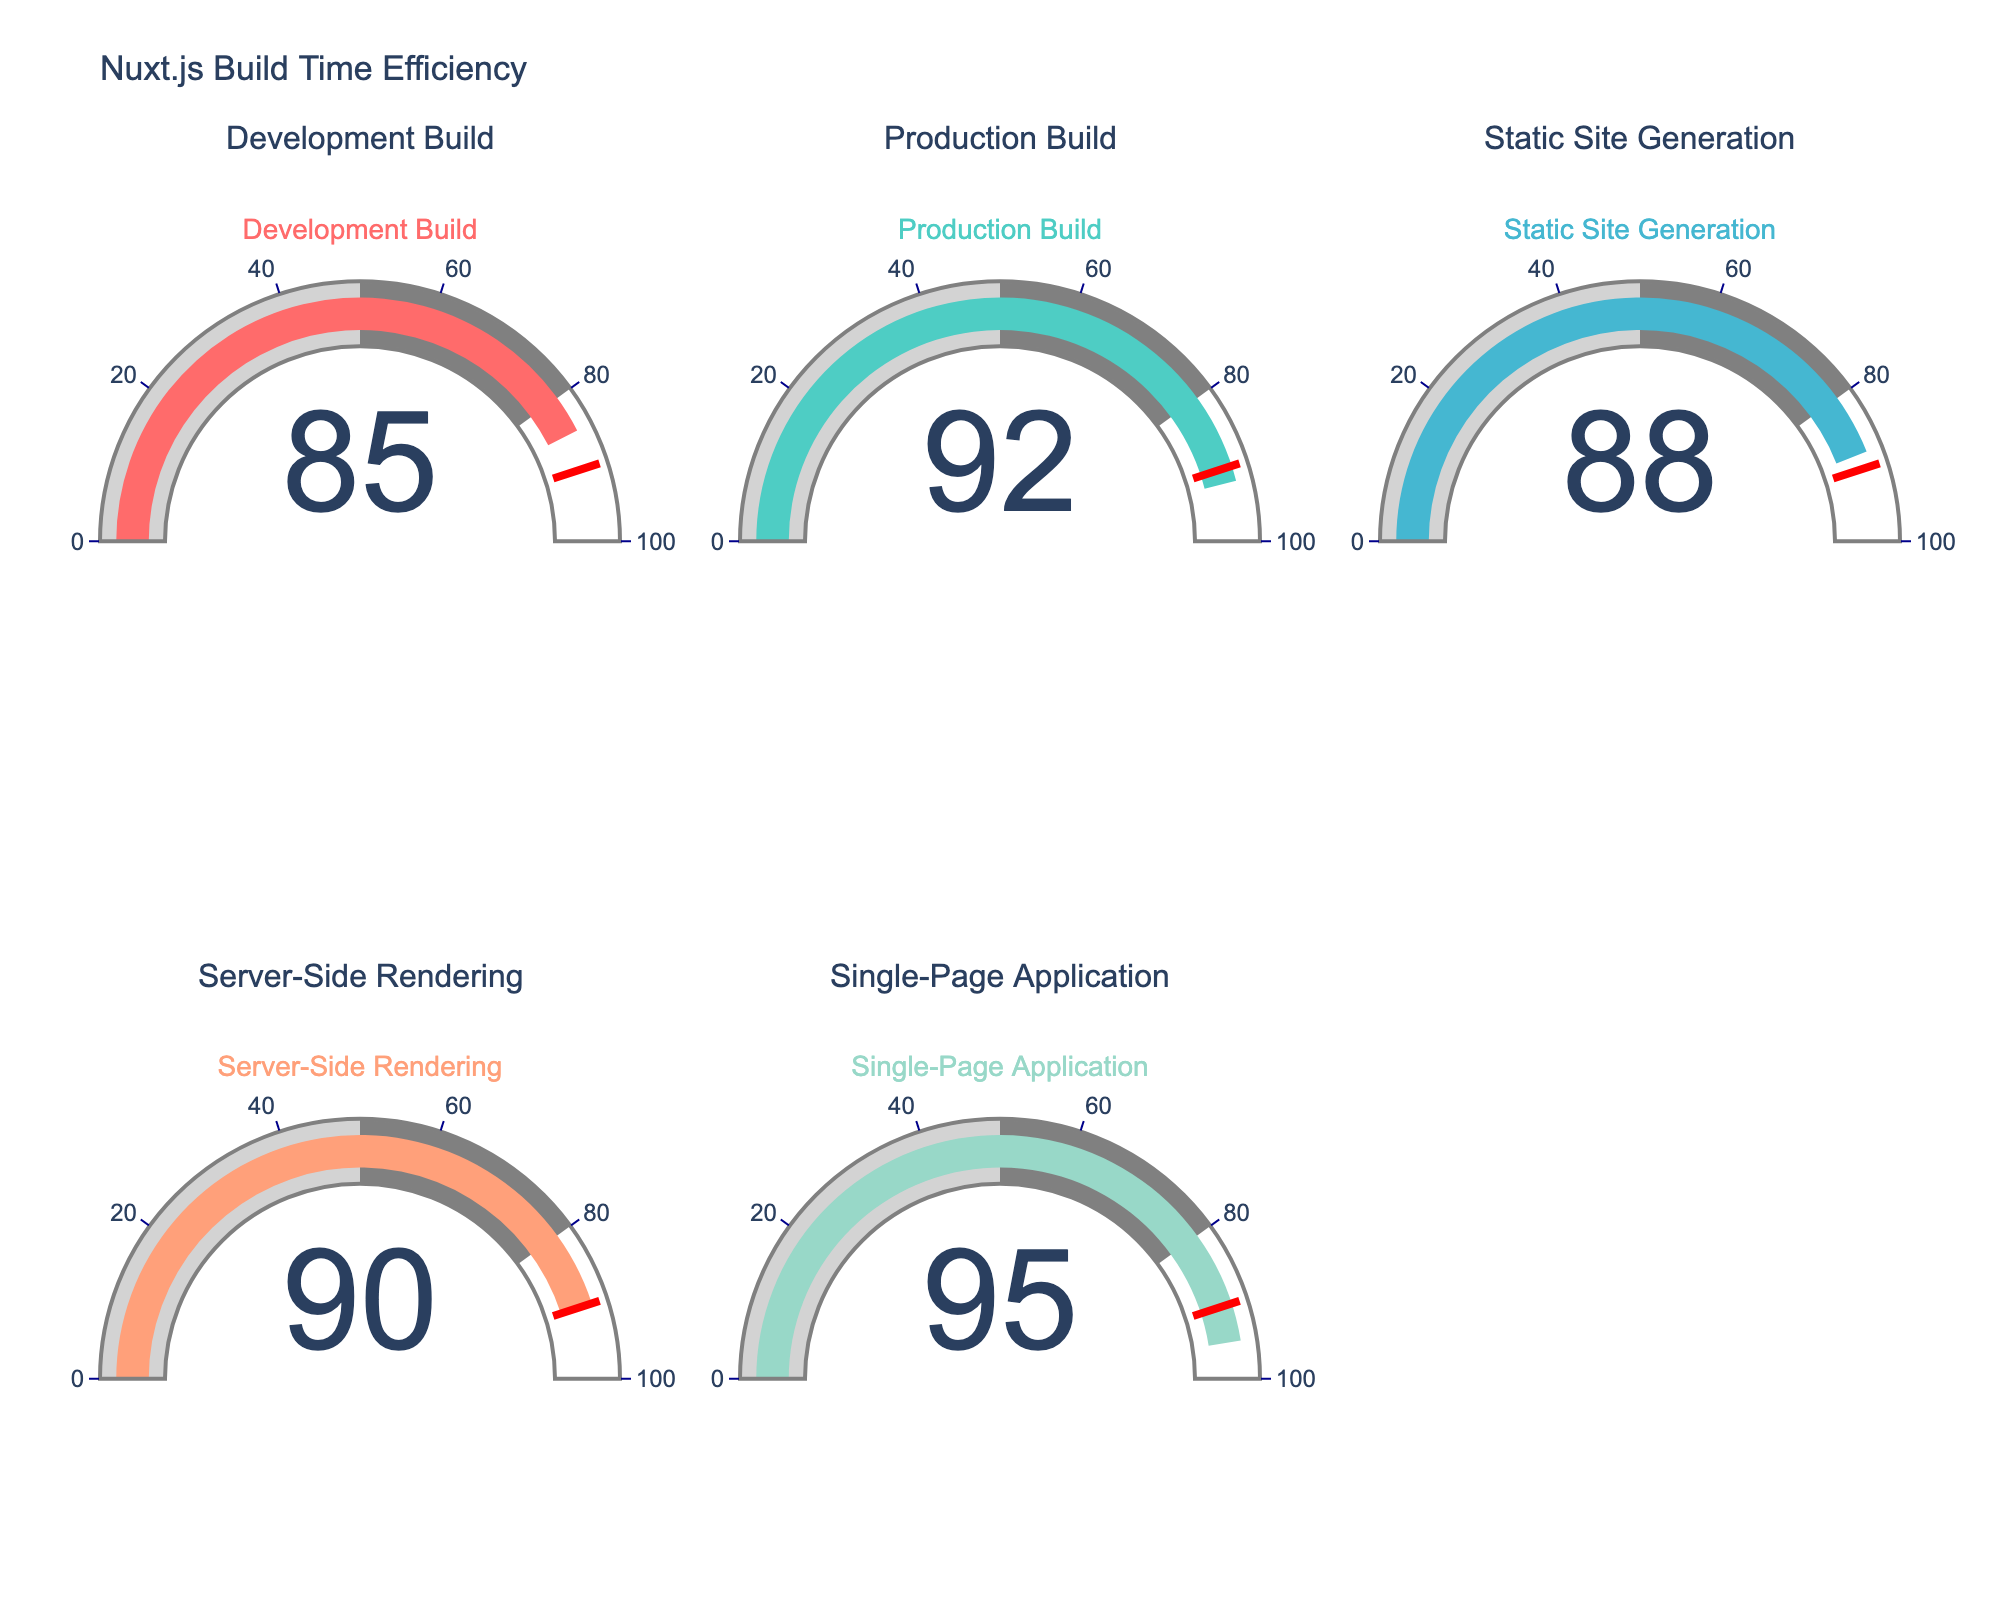What's the title of the figure? The title is located at the top of the chart. It reads "Nuxt.js Build Time Efficiency".
Answer: Nuxt.js Build Time Efficiency Which build type shows the highest efficiency? The gauge chart displays efficiency values for different build types. The build type with the highest efficiency has the number 95 on it, which corresponds to the Single-Page Application.
Answer: Single-Page Application What is the efficiency of the Static Site Generation build? Locate the gauge marked as "Static Site Generation" and read the efficiency value displayed on it. The number next to this build type is 88.
Answer: 88 How many build types have an efficiency of 90% or higher? Count the gauges that display a value of 90% or more. The build types with such efficiencies are Server-Side Rendering (90%), Production Build (92%), and Single-Page Application (95%).
Answer: 3 What is the average efficiency of all build types? Sum the efficiency percentages of all build types: 85 (Development Build) + 92 (Production Build) + 88 (Static Site Generation) + 90 (Server-Side Rendering) + 95 (Single-Page Application). The total is 450. Divide this by the number of build types, which is 5, to get the average efficiency. So, 450 / 5 = 90.
Answer: 90 Which build type has a higher efficiency, Development Build or Server-Side Rendering? Compare the efficiency value displayed on the gauges for the Development Build and Server-Side Rendering. The Development Build shows 85, while Server-Side Rendering shows 90. Thus, Server-Side Rendering has a higher efficiency.
Answer: Server-Side Rendering What is the efficiency difference between the Production Build and the Development Build? Subtract the efficiency of the Development Build from that of the Production Build: 92 (Production Build) - 85 (Development Build). This results in a difference of 7.
Answer: 7 Which build types have an efficiency below 90%? Identify gauges with values less than 90%. These include Development Build (85%) and Static Site Generation (88%).
Answer: Development Build, Static Site Generation 